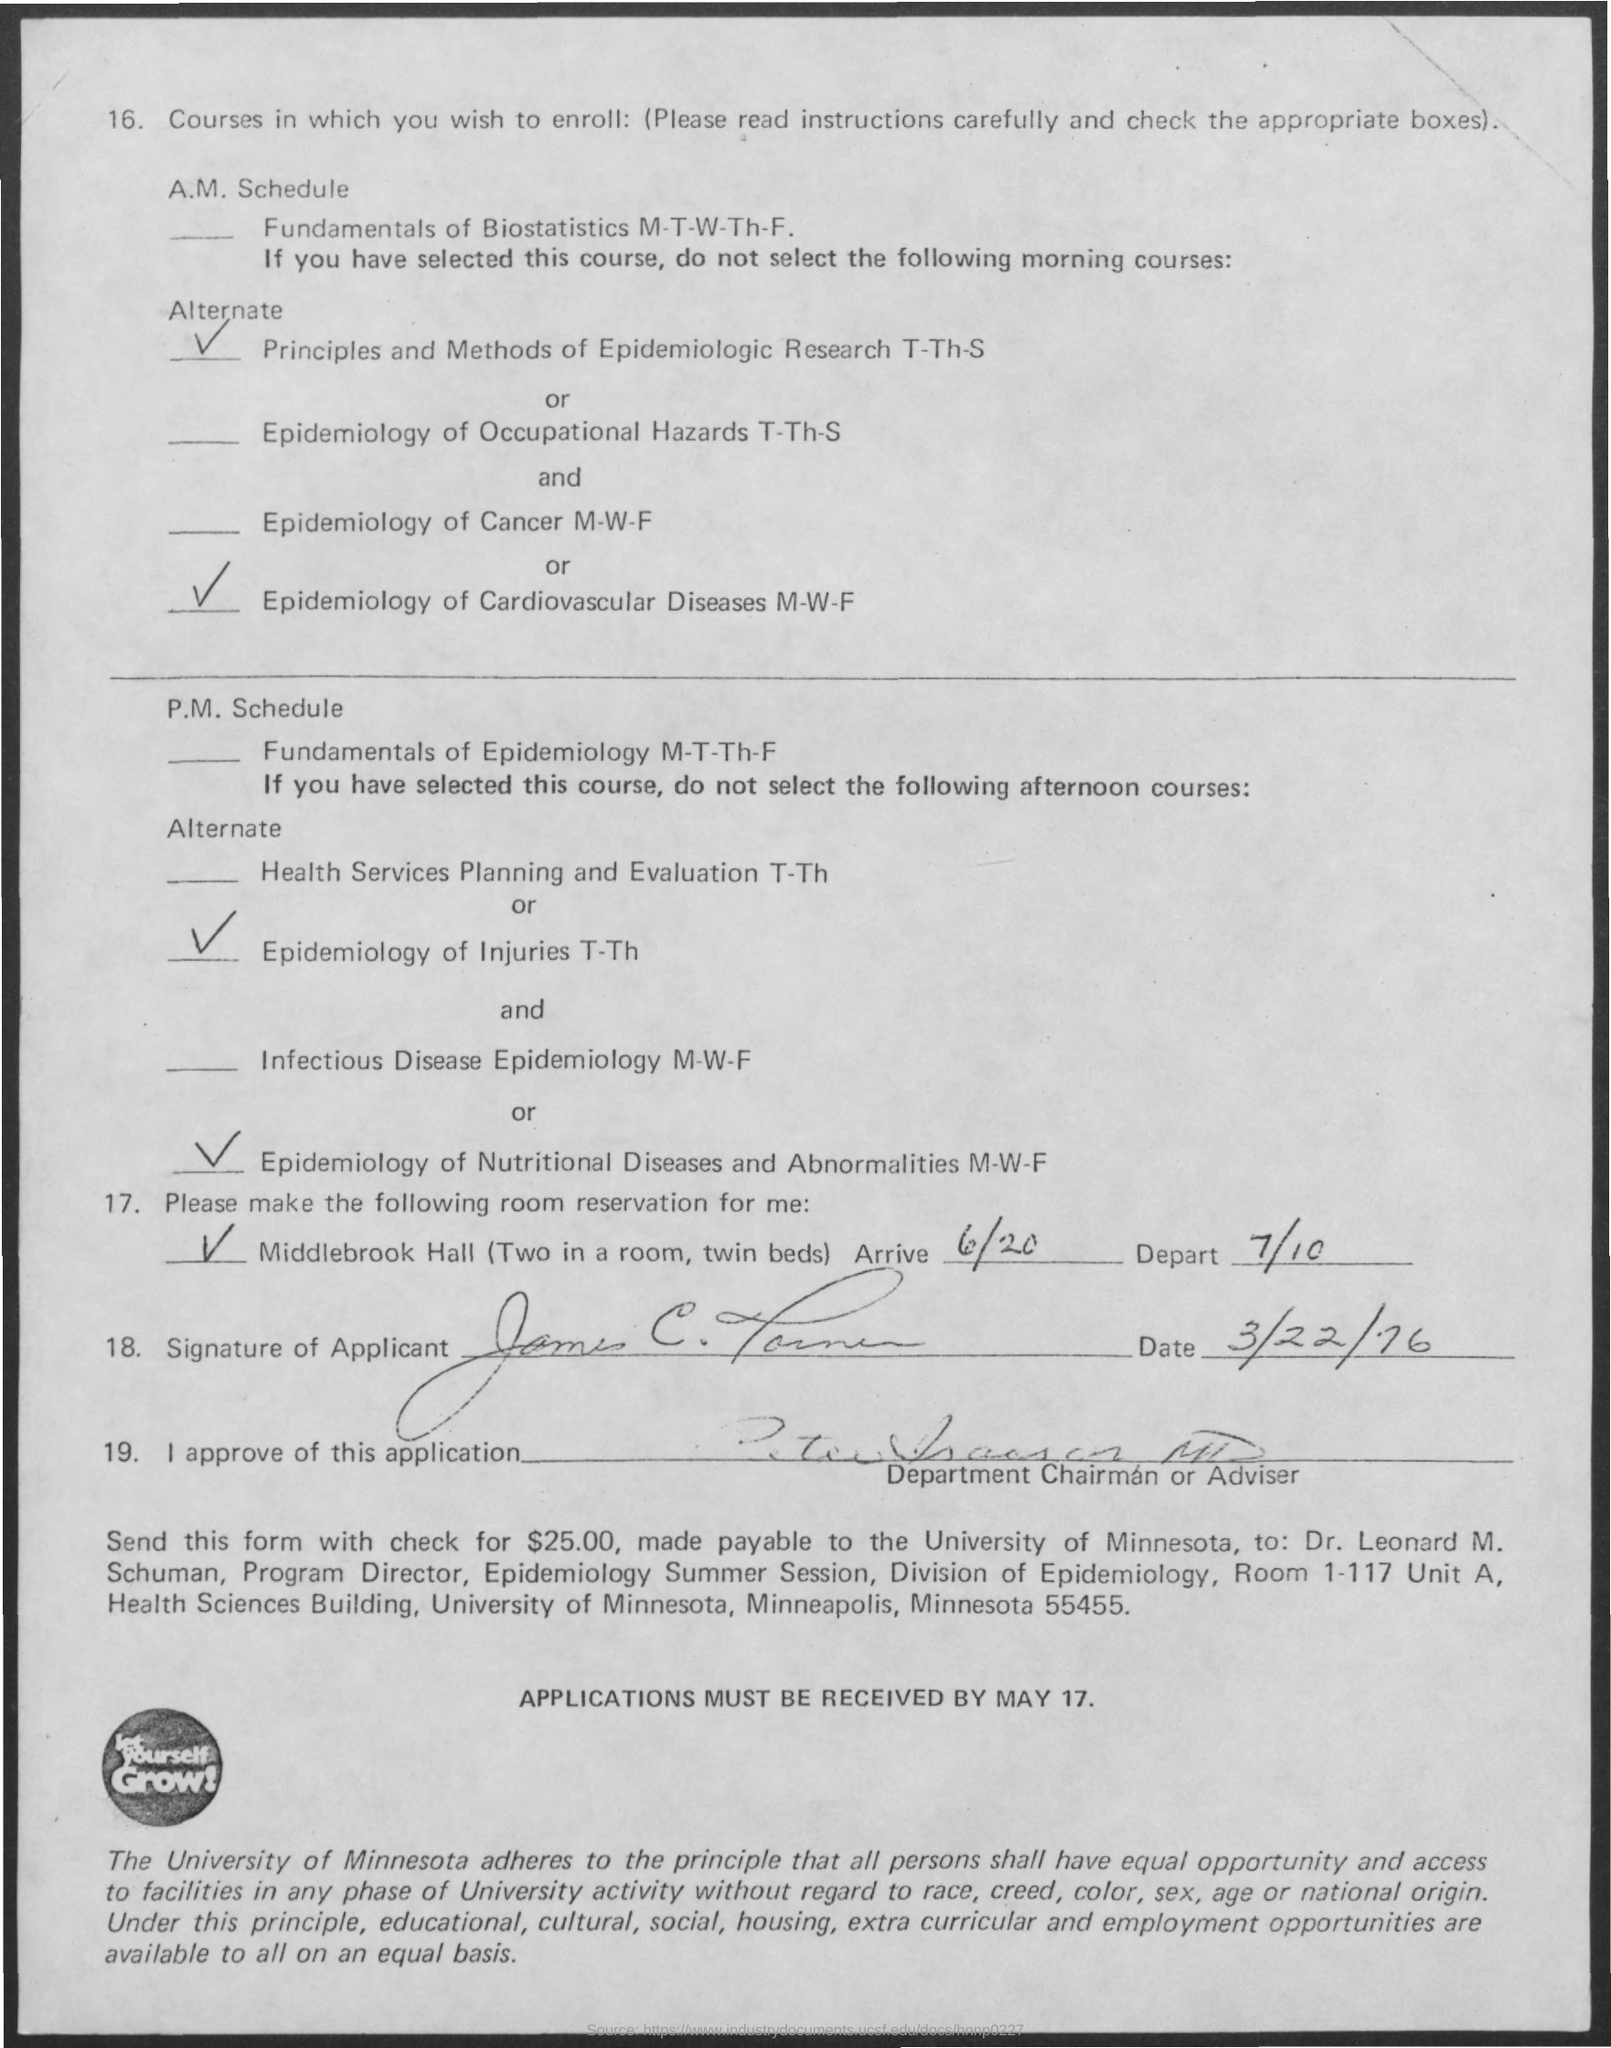When did the applicant signed?
Give a very brief answer. 3/22/76. What is the application receipt date?
Provide a short and direct response. May 17. 